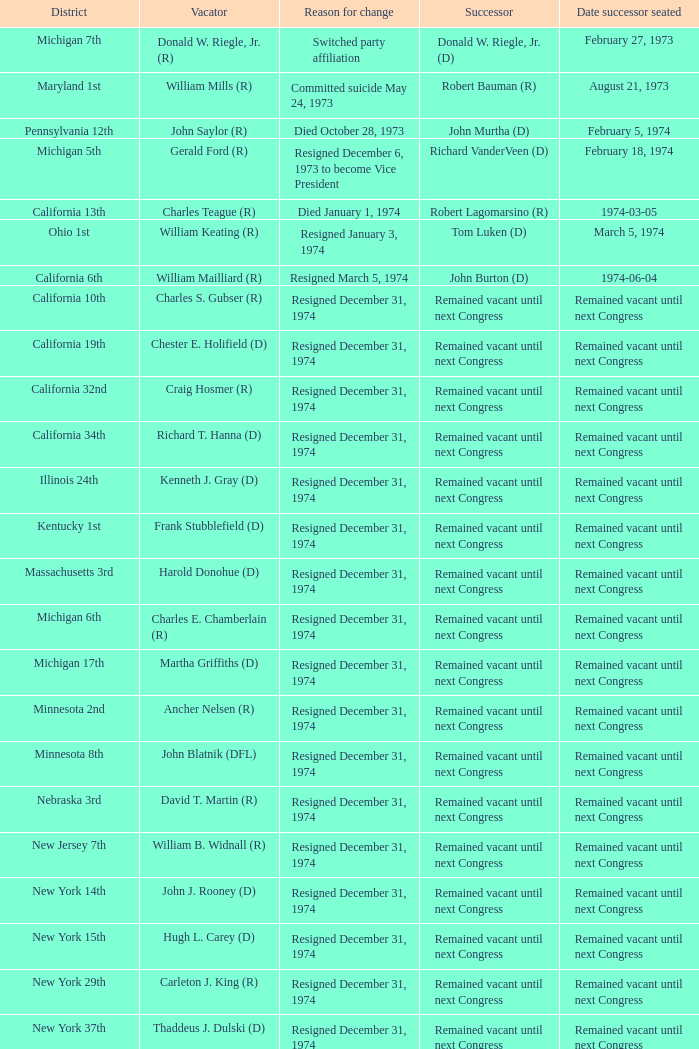Who was the successor when the vacator was chester e. holifield (d)? Remained vacant until next Congress. 